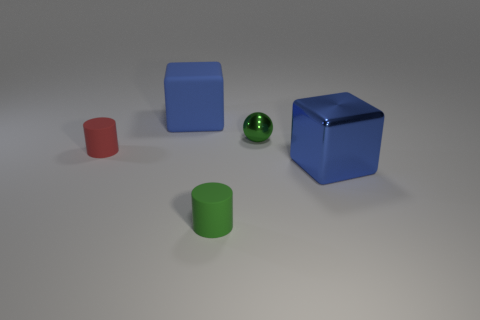Is there any other thing that is the same size as the ball?
Offer a terse response. Yes. What material is the other small thing that is the same shape as the small green matte thing?
Give a very brief answer. Rubber. There is a blue block that is behind the blue cube that is in front of the large blue matte cube; is there a blue object that is behind it?
Offer a very short reply. No. Does the big object behind the big metal object have the same shape as the rubber thing in front of the large blue metal cube?
Keep it short and to the point. No. Is the number of green metal objects behind the tiny green metallic object greater than the number of large yellow metallic cubes?
Your answer should be compact. No. What number of things are red cylinders or matte cylinders?
Your answer should be compact. 2. What color is the sphere?
Your response must be concise. Green. How many other objects are there of the same color as the small ball?
Your answer should be compact. 1. Are there any tiny cylinders behind the red thing?
Make the answer very short. No. What color is the cylinder that is in front of the block in front of the big blue cube behind the blue metallic block?
Your answer should be compact. Green. 